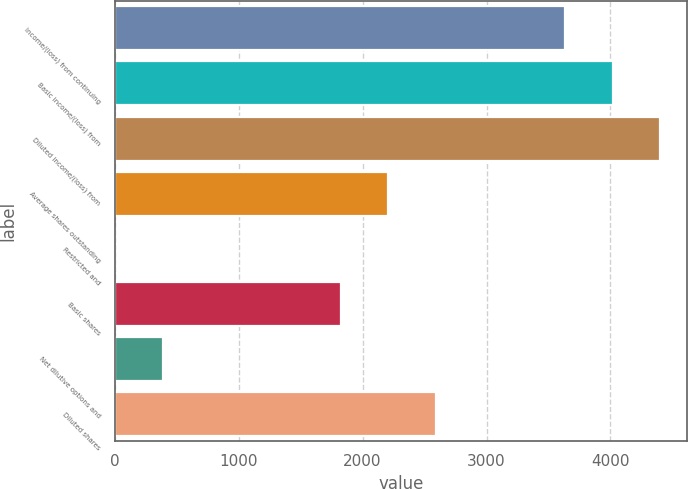Convert chart. <chart><loc_0><loc_0><loc_500><loc_500><bar_chart><fcel>Income/(loss) from continuing<fcel>Basic income/(loss) from<fcel>Diluted income/(loss) from<fcel>Average shares outstanding<fcel>Restricted and<fcel>Basic shares<fcel>Net dilutive options and<fcel>Diluted shares<nl><fcel>3634<fcel>4016.9<fcel>4399.8<fcel>2208.9<fcel>4<fcel>1826<fcel>386.9<fcel>2591.8<nl></chart> 